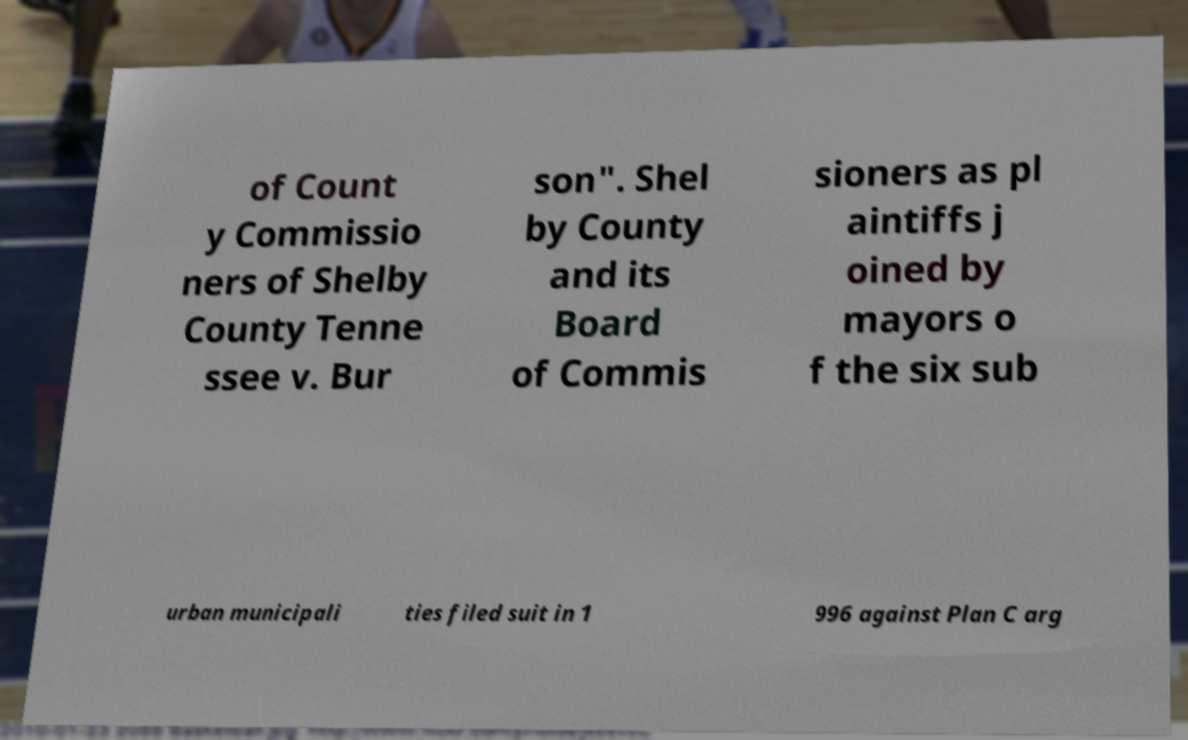I need the written content from this picture converted into text. Can you do that? of Count y Commissio ners of Shelby County Tenne ssee v. Bur son". Shel by County and its Board of Commis sioners as pl aintiffs j oined by mayors o f the six sub urban municipali ties filed suit in 1 996 against Plan C arg 